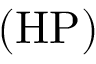<formula> <loc_0><loc_0><loc_500><loc_500>( H P )</formula> 